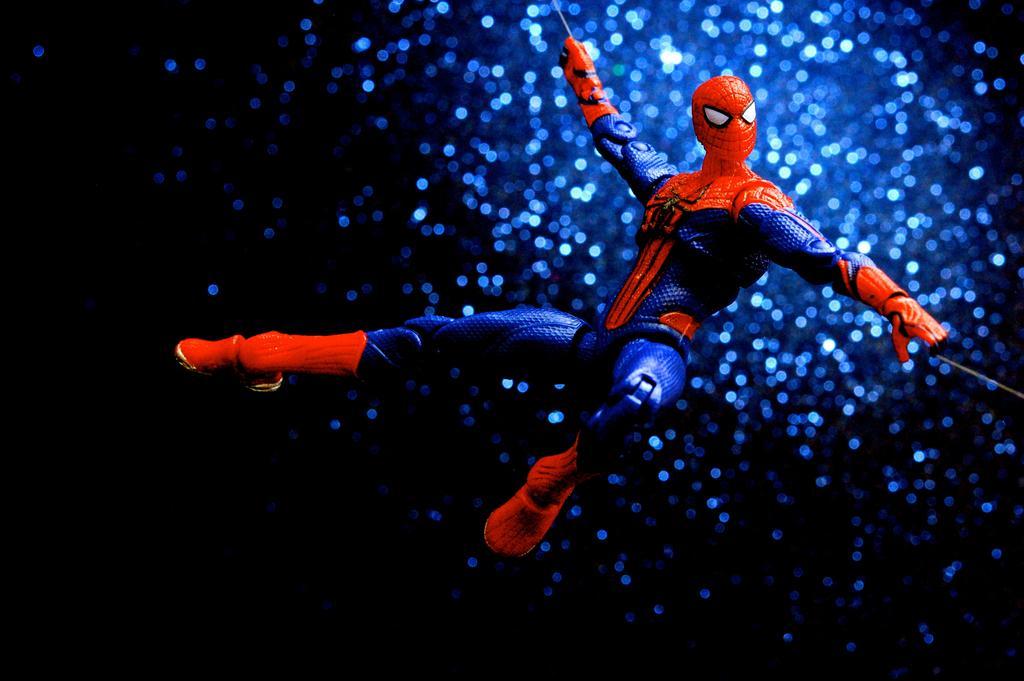Can you describe this image briefly? This image is an animated image. In this image the background is dark and there are a few blue sparkles. In the middle of the image there is a spider man. 